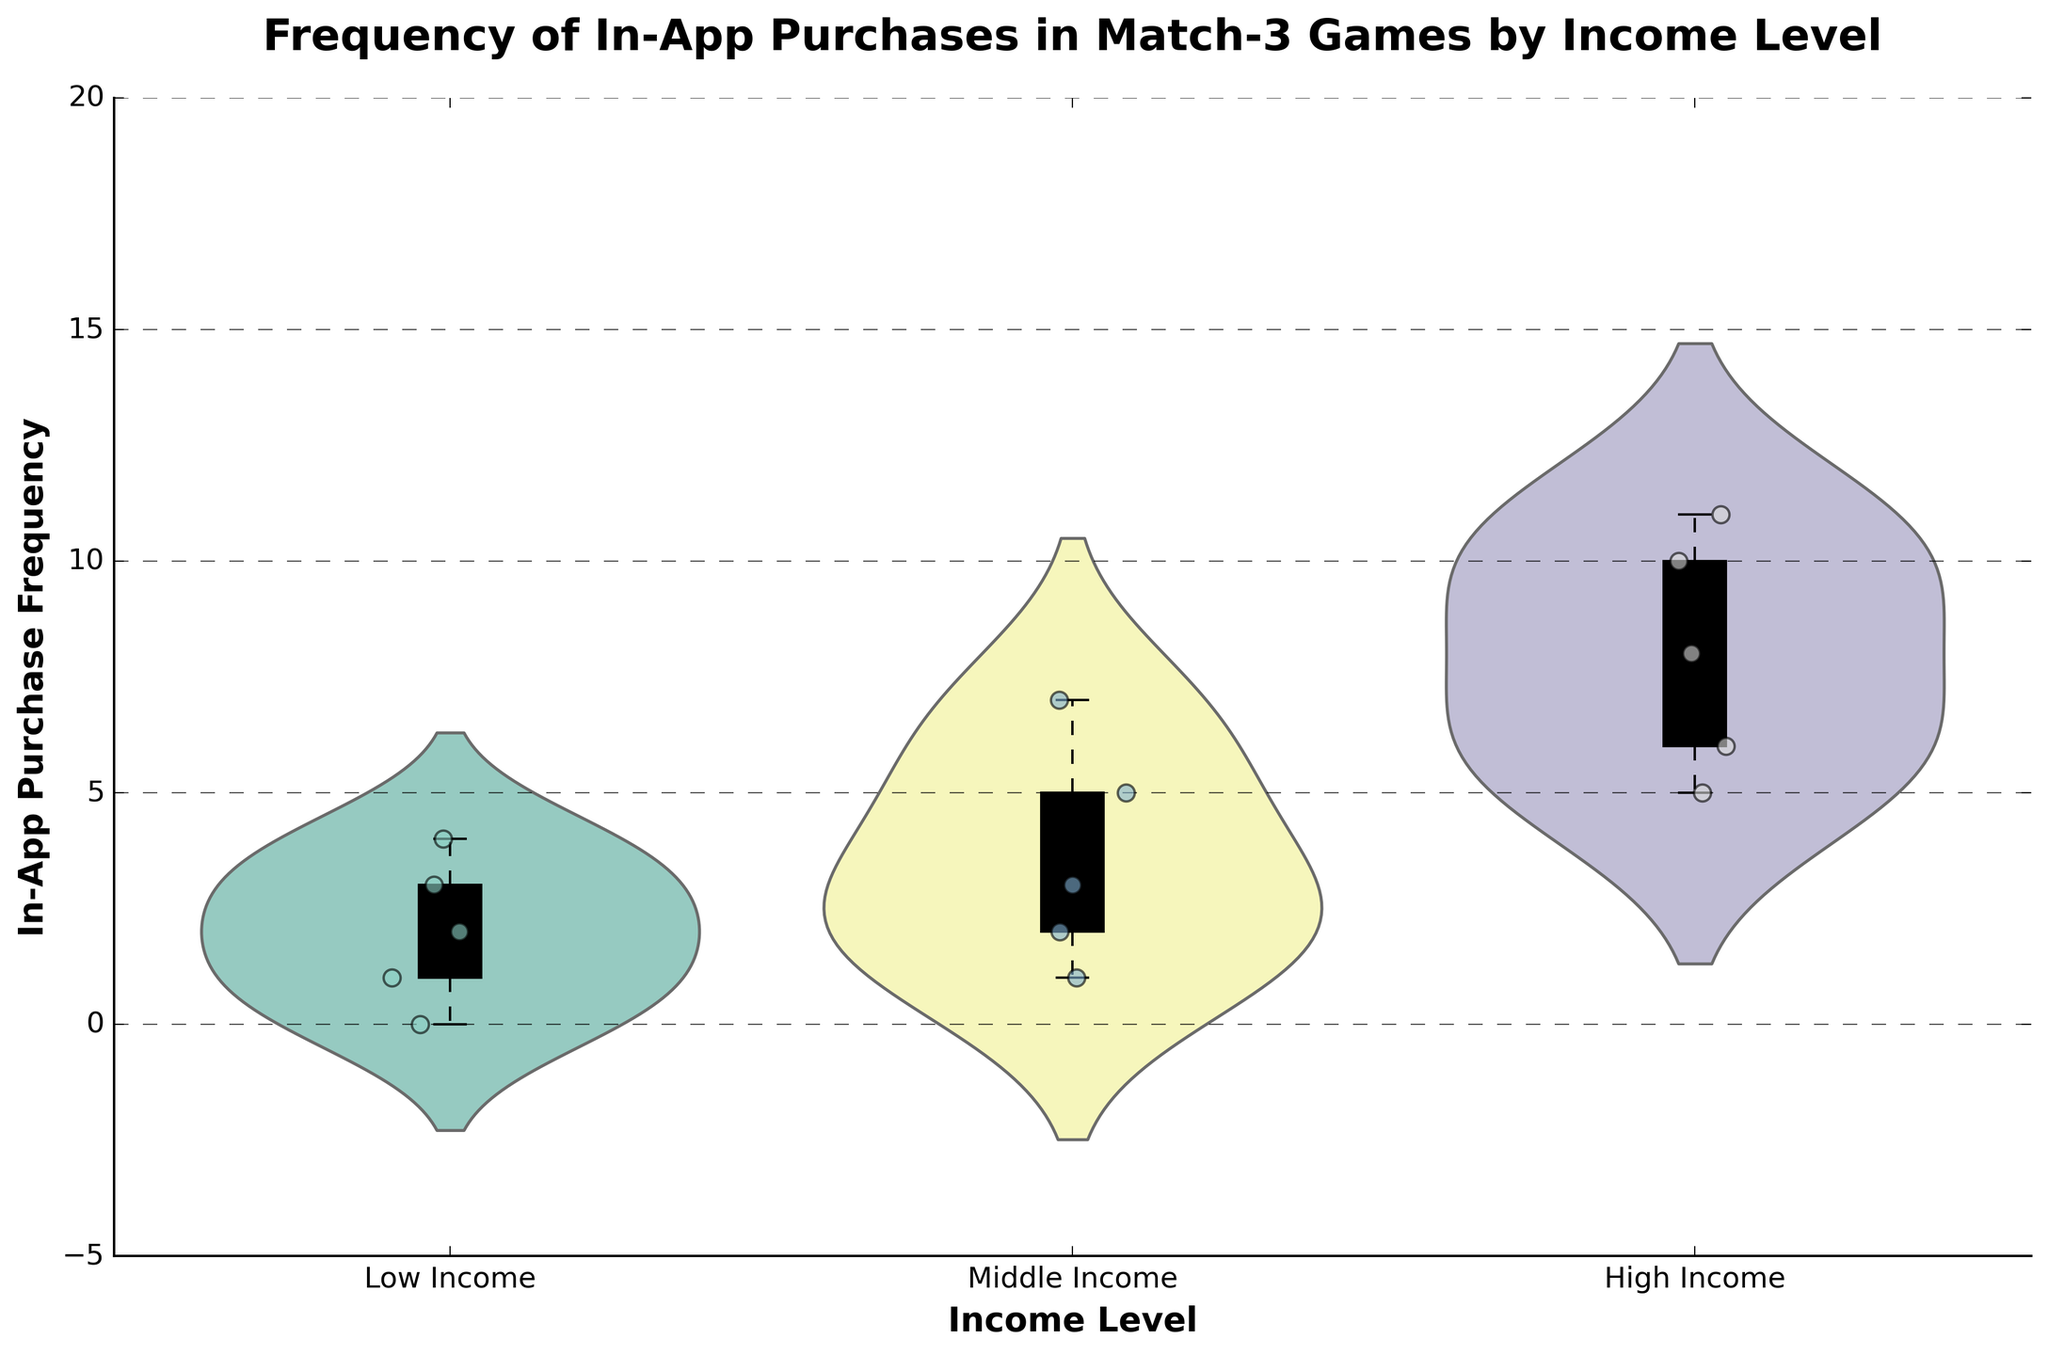What's the title of the figure? The title of the figure is displayed at the top of the plot in a larger font size. It generally summarizes the main subject of the figure.
Answer: Frequency of In-App Purchases in Match-3 Games by Income Level What's the y-axis label? The y-axis label is displayed next to the y-axis and indicates what the vertical values represent. It's in a bold font for emphasis.
Answer: In-App Purchase Frequency Which income level shows the highest variability in the frequency of in-app purchases? Variability can be observed from the width and spread of the violin plot. The wider and more spread out the plot, the higher the variability.
Answer: High Income What is the median in-app purchase frequency for the High Income level? The median is represented by the middle line in the box plot overlay within the High Income violin plot. It denotes the value separating the higher half from the lower half of the data.
Answer: 8 How do the average in-app purchase frequencies of Low Income and Middle Income levels compare? The average can be visually approximated by the distribution inside the violin plot. The Middle Income plot is centered around higher frequencies compared to Low Income.
Answer: Middle Income is higher Which income level has the highest peak density of in-app purchases? The peak density can be identified by the thickest part of the violin plot where the distribution is the densest.
Answer: High Income What’s the interquartile range (IQR) for the Middle Income level? The IQR can be determined by the height of the box in the box plot overlay, which spans from the first quartile (25th percentile) to the third quartile (75th percentile).
Answer: 2 to 5 Compare the number of in-app purchases between the highest frequency user in Low Income and High Income levels. Locate the maximum points in both the Low Income and High Income box plots; compare the numbers directly.
Answer: Low Income: 4, High Income: 11 